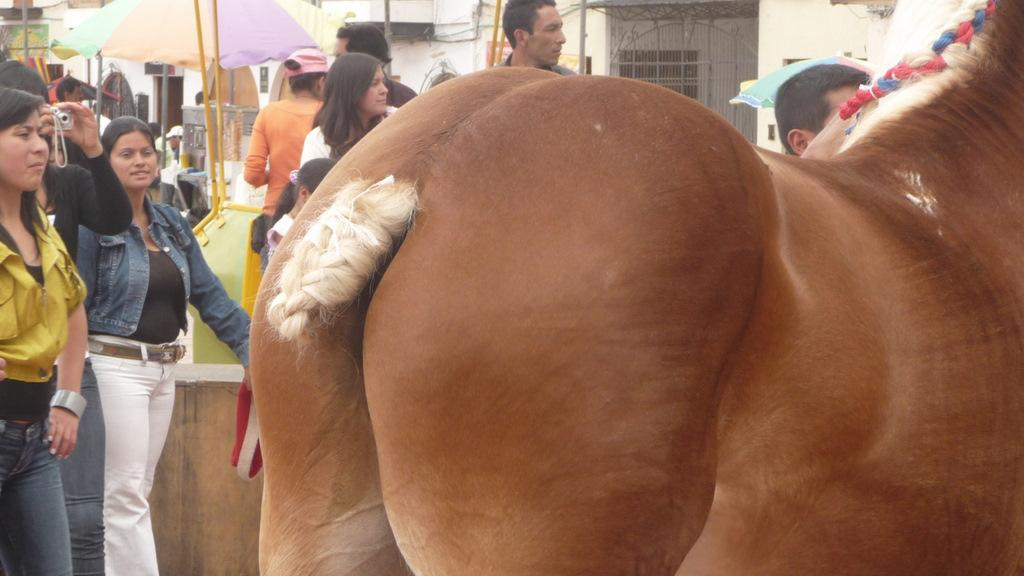What type of animal is in the image? The type of animal cannot be determined from the provided facts. How many people are in the image? There are people in the image, but the exact number cannot be determined from the provided facts. What is the person holding in the image? A person is holding a camera in the image. What can be seen in the background of the image? In the background of the image, there are umbrellas, rods, walls, wires, and other objects. What might be used for protection from the rain in the image? Umbrellas in the background of the image might be used for protection from the rain. What type of roof is visible in the image? There is no mention of a roof in the provided facts, so it cannot be determined from the image. 